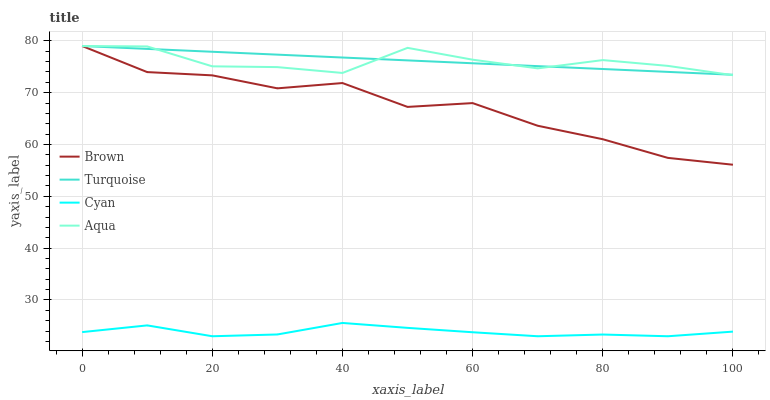Does Cyan have the minimum area under the curve?
Answer yes or no. Yes. Does Turquoise have the maximum area under the curve?
Answer yes or no. Yes. Does Aqua have the minimum area under the curve?
Answer yes or no. No. Does Aqua have the maximum area under the curve?
Answer yes or no. No. Is Turquoise the smoothest?
Answer yes or no. Yes. Is Brown the roughest?
Answer yes or no. Yes. Is Aqua the smoothest?
Answer yes or no. No. Is Aqua the roughest?
Answer yes or no. No. Does Cyan have the lowest value?
Answer yes or no. Yes. Does Aqua have the lowest value?
Answer yes or no. No. Does Aqua have the highest value?
Answer yes or no. Yes. Does Cyan have the highest value?
Answer yes or no. No. Is Cyan less than Aqua?
Answer yes or no. Yes. Is Turquoise greater than Cyan?
Answer yes or no. Yes. Does Aqua intersect Turquoise?
Answer yes or no. Yes. Is Aqua less than Turquoise?
Answer yes or no. No. Is Aqua greater than Turquoise?
Answer yes or no. No. Does Cyan intersect Aqua?
Answer yes or no. No. 